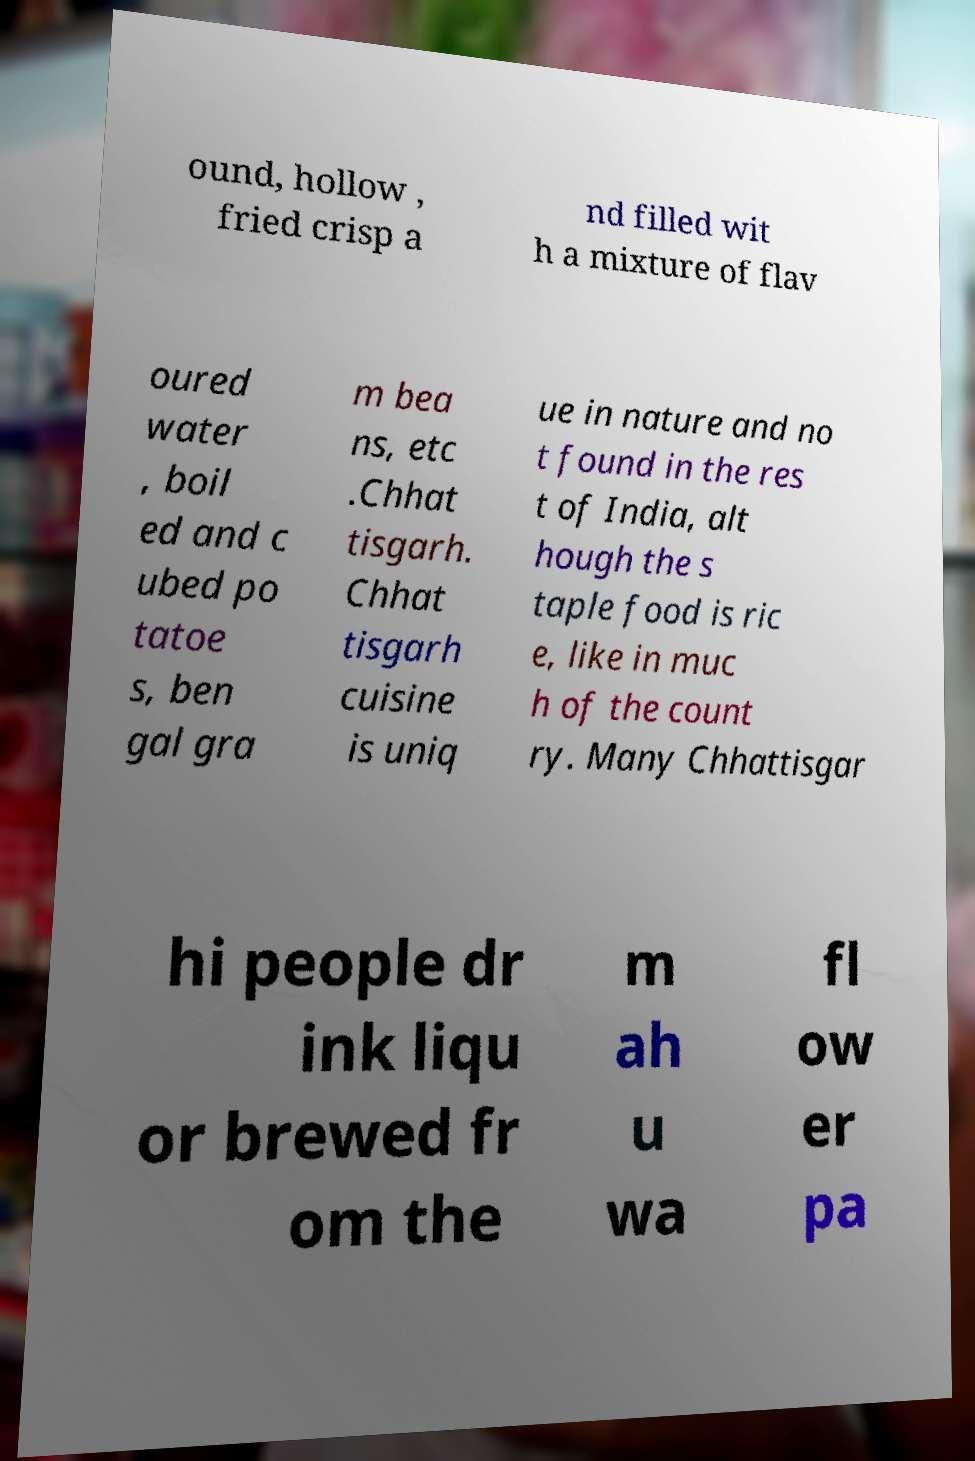There's text embedded in this image that I need extracted. Can you transcribe it verbatim? ound, hollow , fried crisp a nd filled wit h a mixture of flav oured water , boil ed and c ubed po tatoe s, ben gal gra m bea ns, etc .Chhat tisgarh. Chhat tisgarh cuisine is uniq ue in nature and no t found in the res t of India, alt hough the s taple food is ric e, like in muc h of the count ry. Many Chhattisgar hi people dr ink liqu or brewed fr om the m ah u wa fl ow er pa 